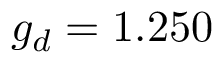<formula> <loc_0><loc_0><loc_500><loc_500>g _ { d } = 1 . 2 5 0</formula> 